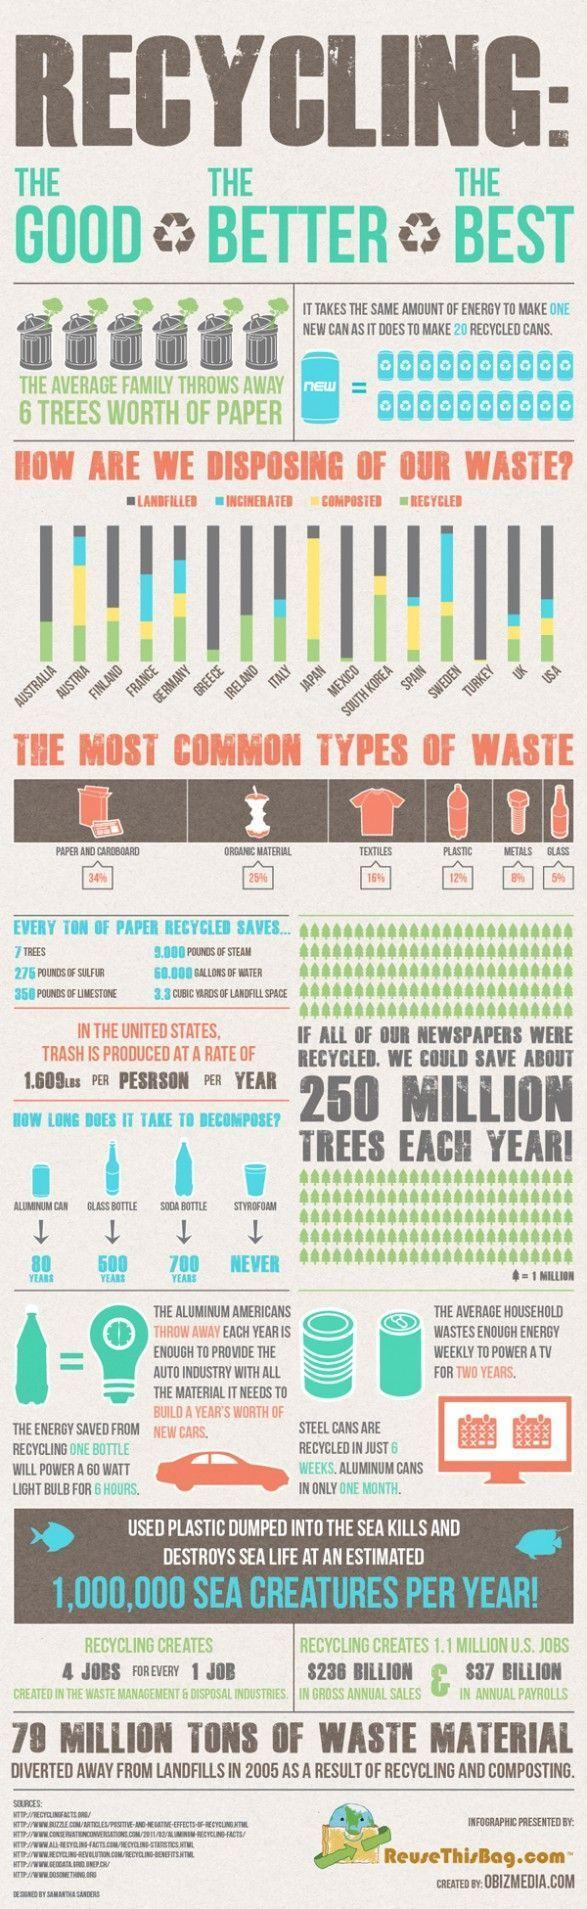Indicate a few pertinent items in this graphic. Australia is effectively managing its waste through a combination of landfill disposal and recycling practices. The combined amount of textiles and metal waste is 24%. The combined amount of plastic and metal waste is approximately 20%. It takes approximately 700 years for a soda bottle to decompose. Japan is effectively managing its waste through a combination of recycling, composting, and responsible landfilling practices, ensuring the country's commitment to sustainability and environmental protection. 